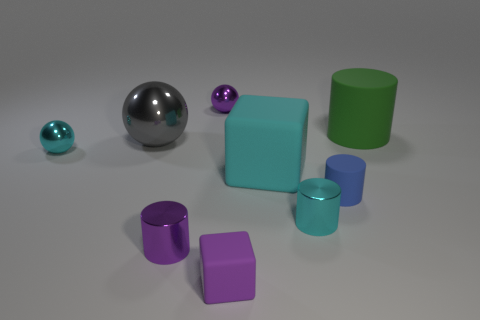Subtract all purple shiny spheres. How many spheres are left? 2 Add 1 small cyan metallic cylinders. How many objects exist? 10 Subtract all blue cylinders. How many cylinders are left? 3 Subtract all green balls. How many yellow cylinders are left? 0 Subtract all spheres. Subtract all large rubber cylinders. How many objects are left? 5 Add 5 big green matte objects. How many big green matte objects are left? 6 Add 7 large green blocks. How many large green blocks exist? 7 Subtract 1 purple cubes. How many objects are left? 8 Subtract all cylinders. How many objects are left? 5 Subtract 2 spheres. How many spheres are left? 1 